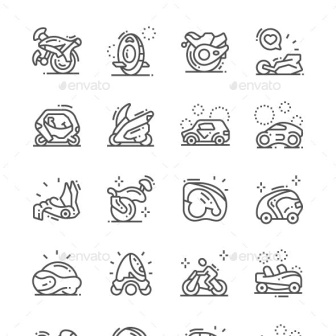Describe the following image. The image presents a neat collection of sixteen black and white line icons, each representing a different mode of transportation. They are organized in a grid of four rows and four columns. 

Starting from the top left, the first icon is a bicycle, followed by a compass, a rocket ship, and a person on a sled, completing the first row. The second row begins with a car, then a person on a snowmobile, a person in a car, and a person on a motorcycle. 

The third row starts with a person on a skateboard, followed by a person on a jet ski, a person on a surfboard, and a person on a scooter. The final row begins with a person on a skateboard, followed by a person on a bicycle, a person on a motorcycle, and ends with a person on a skateboard.

Each icon is a simple line drawing, and they all share a common white background. The icons are evenly spaced, creating a harmonious and balanced visual effect. The image as a whole provides a comprehensive overview of various modes of transportation, from the traditional to the adventurous. 